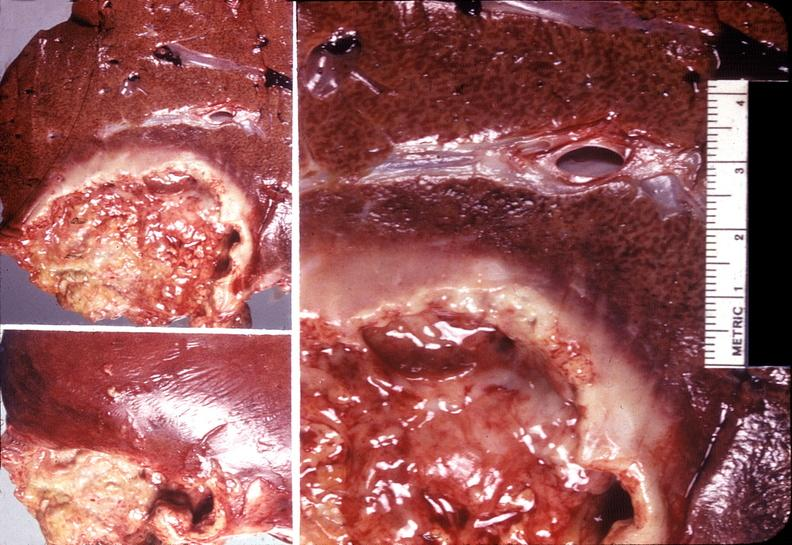s hepatobiliary present?
Answer the question using a single word or phrase. Yes 